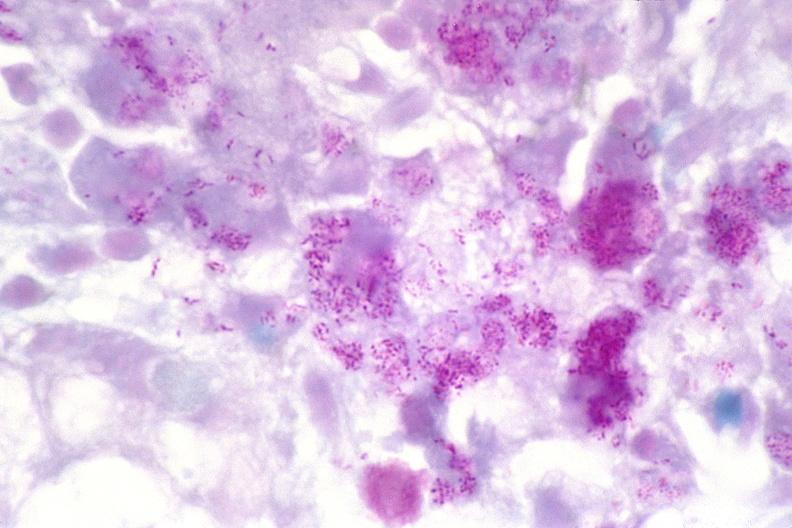what stain?
Answer the question using a single word or phrase. Acid 